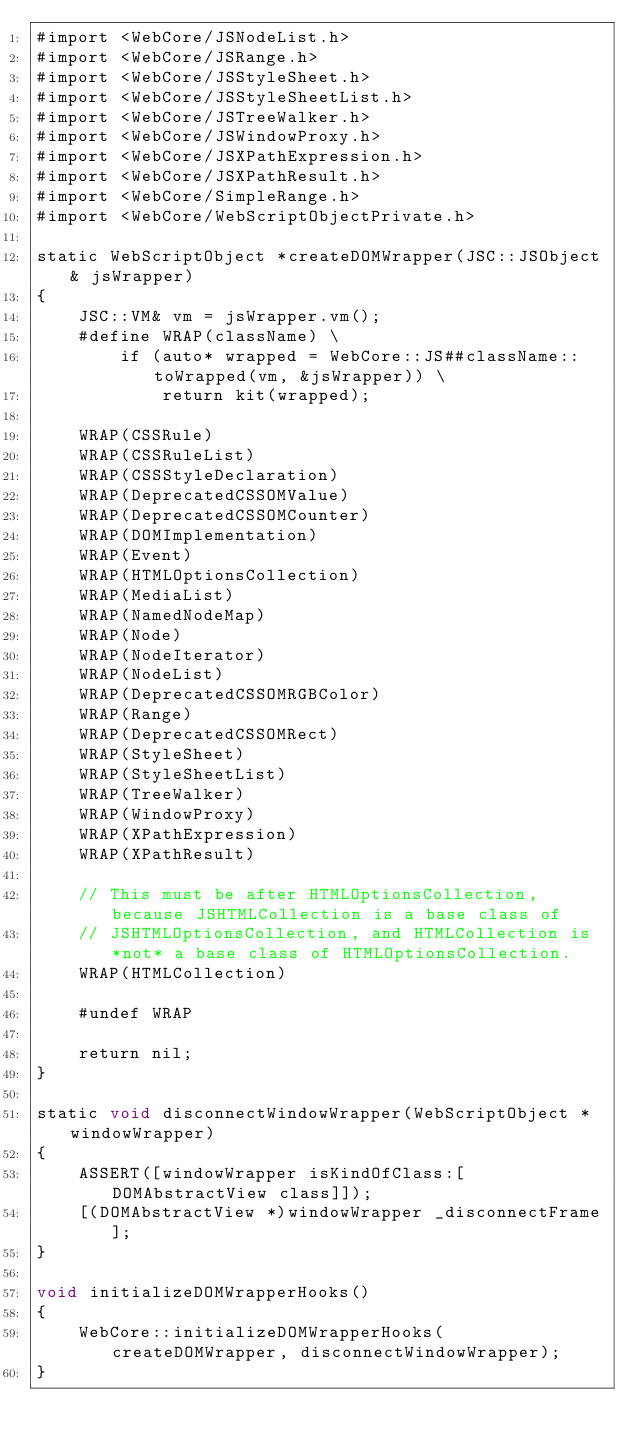Convert code to text. <code><loc_0><loc_0><loc_500><loc_500><_ObjectiveC_>#import <WebCore/JSNodeList.h>
#import <WebCore/JSRange.h>
#import <WebCore/JSStyleSheet.h>
#import <WebCore/JSStyleSheetList.h>
#import <WebCore/JSTreeWalker.h>
#import <WebCore/JSWindowProxy.h>
#import <WebCore/JSXPathExpression.h>
#import <WebCore/JSXPathResult.h>
#import <WebCore/SimpleRange.h>
#import <WebCore/WebScriptObjectPrivate.h>

static WebScriptObject *createDOMWrapper(JSC::JSObject& jsWrapper)
{
    JSC::VM& vm = jsWrapper.vm();
    #define WRAP(className) \
        if (auto* wrapped = WebCore::JS##className::toWrapped(vm, &jsWrapper)) \
            return kit(wrapped);

    WRAP(CSSRule)
    WRAP(CSSRuleList)
    WRAP(CSSStyleDeclaration)
    WRAP(DeprecatedCSSOMValue)
    WRAP(DeprecatedCSSOMCounter)
    WRAP(DOMImplementation)
    WRAP(Event)
    WRAP(HTMLOptionsCollection)
    WRAP(MediaList)
    WRAP(NamedNodeMap)
    WRAP(Node)
    WRAP(NodeIterator)
    WRAP(NodeList)
    WRAP(DeprecatedCSSOMRGBColor)
    WRAP(Range)
    WRAP(DeprecatedCSSOMRect)
    WRAP(StyleSheet)
    WRAP(StyleSheetList)
    WRAP(TreeWalker)
    WRAP(WindowProxy)
    WRAP(XPathExpression)
    WRAP(XPathResult)

    // This must be after HTMLOptionsCollection, because JSHTMLCollection is a base class of
    // JSHTMLOptionsCollection, and HTMLCollection is *not* a base class of HTMLOptionsCollection.
    WRAP(HTMLCollection)

    #undef WRAP

    return nil;
}

static void disconnectWindowWrapper(WebScriptObject *windowWrapper)
{
    ASSERT([windowWrapper isKindOfClass:[DOMAbstractView class]]);
    [(DOMAbstractView *)windowWrapper _disconnectFrame];
}

void initializeDOMWrapperHooks()
{
    WebCore::initializeDOMWrapperHooks(createDOMWrapper, disconnectWindowWrapper);
}
</code> 